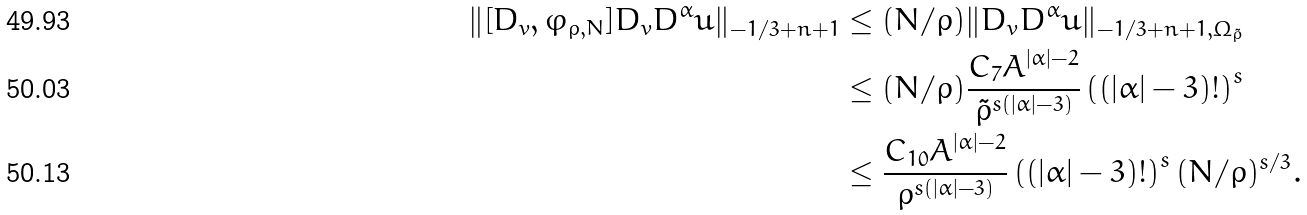Convert formula to latex. <formula><loc_0><loc_0><loc_500><loc_500>\| [ D _ { v } , \varphi _ { \rho , N } ] D _ { v } D ^ { \alpha } u \| _ { - 1 / 3 + n + 1 } & \leq ( N / \rho ) \| D _ { v } D ^ { \alpha } u \| _ { - 1 / 3 + n + 1 , \Omega _ { \tilde { \rho } } } \\ & \leq ( N / \rho ) \frac { C _ { 7 } A ^ { | \alpha | - 2 } } { { \tilde { \rho } } ^ { s ( | \alpha | - 3 ) } } \left ( ( | \alpha | - 3 ) ! \right ) ^ { s } \\ & \leq \frac { C _ { 1 0 } A ^ { | \alpha | - 2 } } { { \rho } ^ { s ( | \alpha | - 3 ) } } \left ( ( | \alpha | - 3 ) ! \right ) ^ { s } ( N / \rho ) ^ { s / 3 } .</formula> 